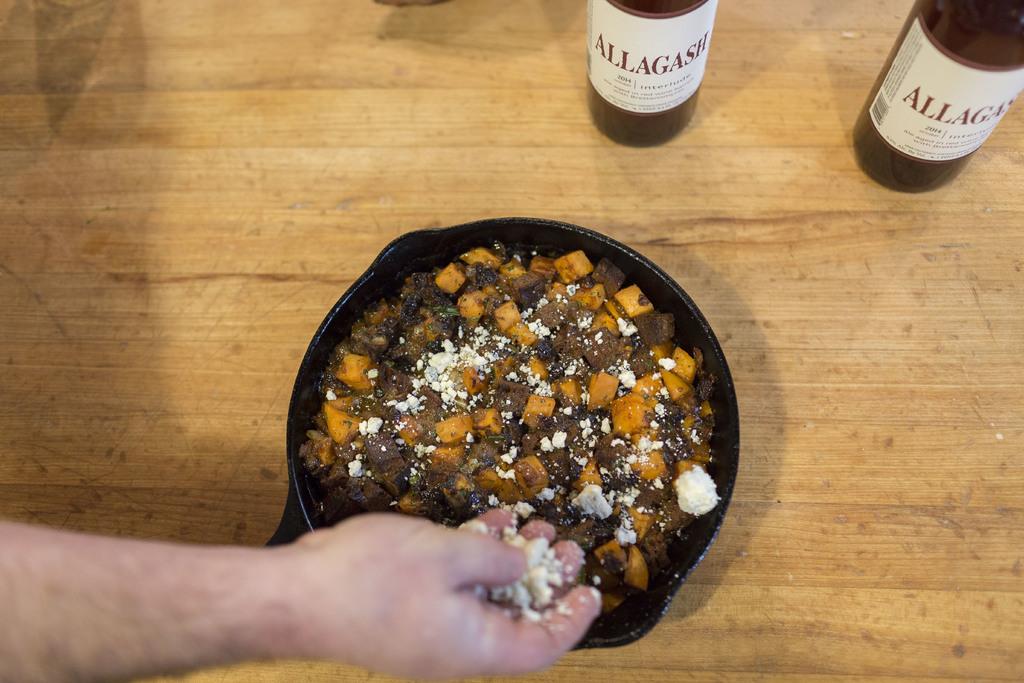What kind of drink is being served?
Ensure brevity in your answer.  Allagash. 